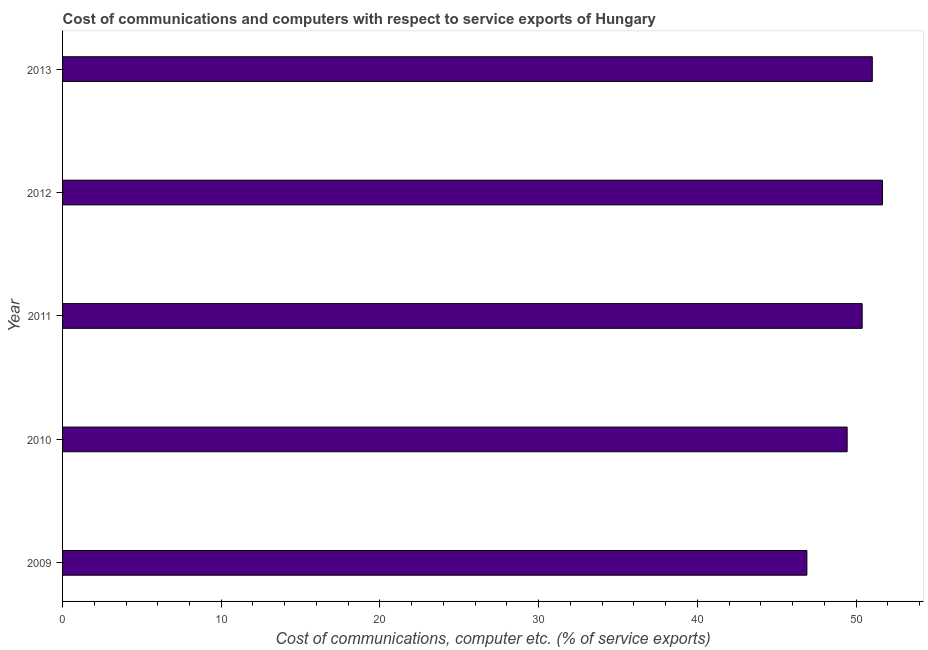Does the graph contain grids?
Make the answer very short. No. What is the title of the graph?
Make the answer very short. Cost of communications and computers with respect to service exports of Hungary. What is the label or title of the X-axis?
Your answer should be compact. Cost of communications, computer etc. (% of service exports). What is the label or title of the Y-axis?
Ensure brevity in your answer.  Year. What is the cost of communications and computer in 2010?
Provide a succinct answer. 49.44. Across all years, what is the maximum cost of communications and computer?
Your answer should be very brief. 51.67. Across all years, what is the minimum cost of communications and computer?
Your answer should be compact. 46.9. In which year was the cost of communications and computer maximum?
Provide a succinct answer. 2012. In which year was the cost of communications and computer minimum?
Provide a short and direct response. 2009. What is the sum of the cost of communications and computer?
Your response must be concise. 249.43. What is the difference between the cost of communications and computer in 2009 and 2012?
Make the answer very short. -4.76. What is the average cost of communications and computer per year?
Keep it short and to the point. 49.89. What is the median cost of communications and computer?
Make the answer very short. 50.39. What is the ratio of the cost of communications and computer in 2011 to that in 2012?
Your answer should be very brief. 0.97. What is the difference between the highest and the second highest cost of communications and computer?
Provide a short and direct response. 0.64. What is the difference between the highest and the lowest cost of communications and computer?
Keep it short and to the point. 4.76. How many bars are there?
Provide a short and direct response. 5. How many years are there in the graph?
Ensure brevity in your answer.  5. Are the values on the major ticks of X-axis written in scientific E-notation?
Provide a succinct answer. No. What is the Cost of communications, computer etc. (% of service exports) in 2009?
Provide a short and direct response. 46.9. What is the Cost of communications, computer etc. (% of service exports) of 2010?
Give a very brief answer. 49.44. What is the Cost of communications, computer etc. (% of service exports) in 2011?
Provide a short and direct response. 50.39. What is the Cost of communications, computer etc. (% of service exports) in 2012?
Offer a terse response. 51.67. What is the Cost of communications, computer etc. (% of service exports) in 2013?
Your answer should be compact. 51.03. What is the difference between the Cost of communications, computer etc. (% of service exports) in 2009 and 2010?
Provide a short and direct response. -2.54. What is the difference between the Cost of communications, computer etc. (% of service exports) in 2009 and 2011?
Offer a terse response. -3.48. What is the difference between the Cost of communications, computer etc. (% of service exports) in 2009 and 2012?
Your answer should be very brief. -4.76. What is the difference between the Cost of communications, computer etc. (% of service exports) in 2009 and 2013?
Ensure brevity in your answer.  -4.12. What is the difference between the Cost of communications, computer etc. (% of service exports) in 2010 and 2011?
Provide a succinct answer. -0.95. What is the difference between the Cost of communications, computer etc. (% of service exports) in 2010 and 2012?
Offer a terse response. -2.23. What is the difference between the Cost of communications, computer etc. (% of service exports) in 2010 and 2013?
Your response must be concise. -1.59. What is the difference between the Cost of communications, computer etc. (% of service exports) in 2011 and 2012?
Give a very brief answer. -1.28. What is the difference between the Cost of communications, computer etc. (% of service exports) in 2011 and 2013?
Your response must be concise. -0.64. What is the difference between the Cost of communications, computer etc. (% of service exports) in 2012 and 2013?
Offer a very short reply. 0.64. What is the ratio of the Cost of communications, computer etc. (% of service exports) in 2009 to that in 2010?
Your answer should be very brief. 0.95. What is the ratio of the Cost of communications, computer etc. (% of service exports) in 2009 to that in 2011?
Offer a terse response. 0.93. What is the ratio of the Cost of communications, computer etc. (% of service exports) in 2009 to that in 2012?
Your response must be concise. 0.91. What is the ratio of the Cost of communications, computer etc. (% of service exports) in 2009 to that in 2013?
Keep it short and to the point. 0.92. What is the ratio of the Cost of communications, computer etc. (% of service exports) in 2010 to that in 2013?
Ensure brevity in your answer.  0.97. What is the ratio of the Cost of communications, computer etc. (% of service exports) in 2011 to that in 2013?
Provide a short and direct response. 0.99. 